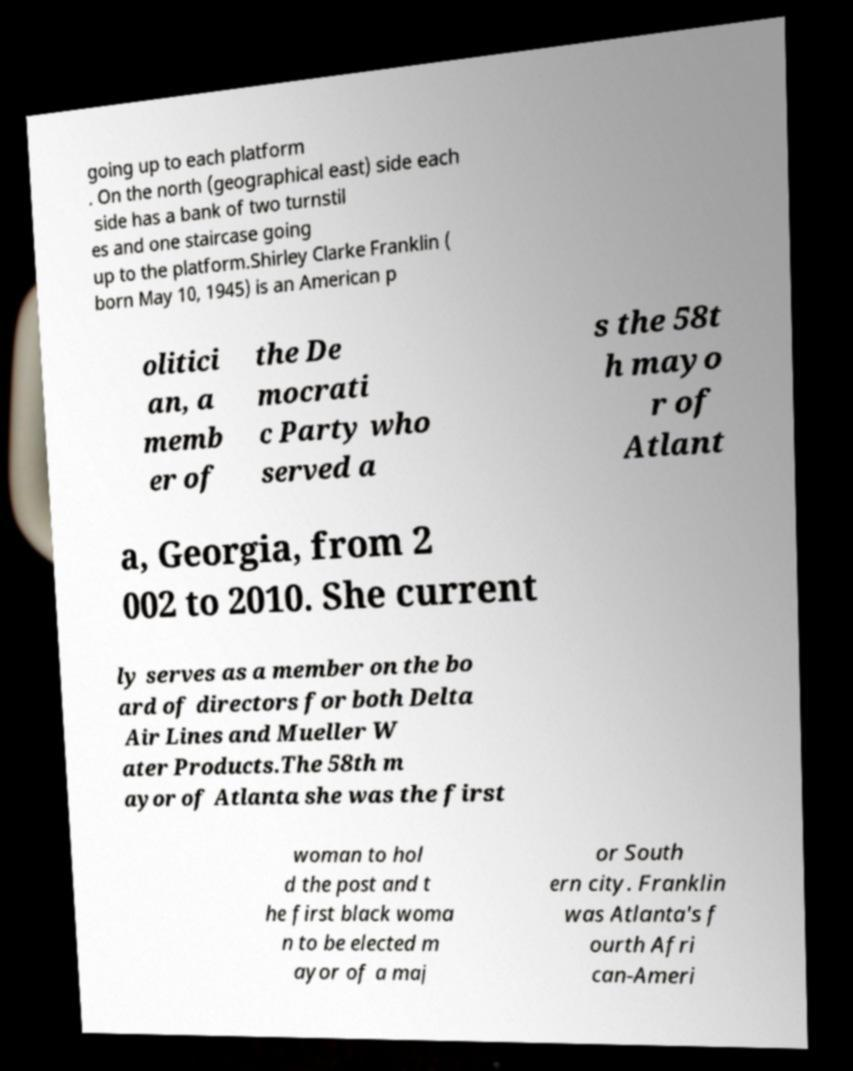There's text embedded in this image that I need extracted. Can you transcribe it verbatim? going up to each platform . On the north (geographical east) side each side has a bank of two turnstil es and one staircase going up to the platform.Shirley Clarke Franklin ( born May 10, 1945) is an American p olitici an, a memb er of the De mocrati c Party who served a s the 58t h mayo r of Atlant a, Georgia, from 2 002 to 2010. She current ly serves as a member on the bo ard of directors for both Delta Air Lines and Mueller W ater Products.The 58th m ayor of Atlanta she was the first woman to hol d the post and t he first black woma n to be elected m ayor of a maj or South ern city. Franklin was Atlanta's f ourth Afri can-Ameri 